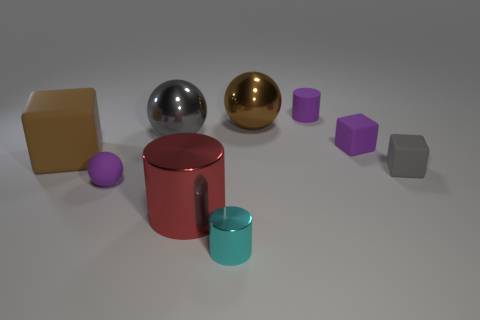What number of small rubber things have the same color as the tiny metal cylinder?
Ensure brevity in your answer.  0. There is a shiny cylinder that is behind the tiny cyan thing; is there a big brown rubber object in front of it?
Offer a very short reply. No. What number of tiny things are both on the right side of the large gray object and behind the red cylinder?
Give a very brief answer. 3. What number of big cubes are made of the same material as the big gray thing?
Offer a terse response. 0. There is a sphere in front of the small purple matte thing that is on the right side of the rubber cylinder; what size is it?
Ensure brevity in your answer.  Small. Are there any gray rubber things that have the same shape as the big red metal object?
Offer a terse response. No. Does the brown object that is right of the tiny rubber ball have the same size as the rubber cube that is behind the big rubber thing?
Provide a succinct answer. No. Are there fewer purple rubber things behind the large brown shiny thing than tiny purple objects that are right of the gray matte object?
Offer a very short reply. No. There is a small cylinder that is the same color as the small matte ball; what is it made of?
Provide a short and direct response. Rubber. What color is the matte block that is left of the tiny metallic object?
Your answer should be compact. Brown. 